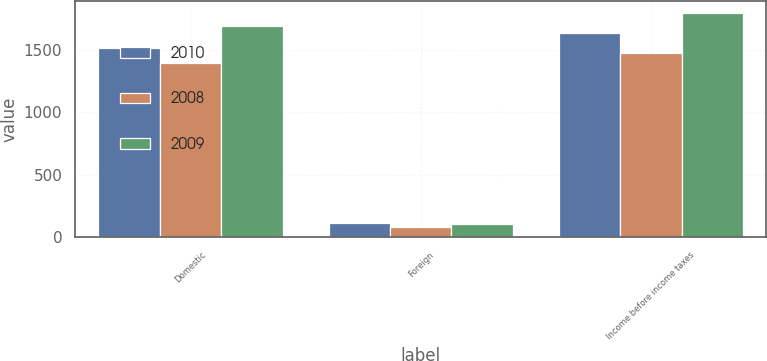Convert chart to OTSL. <chart><loc_0><loc_0><loc_500><loc_500><stacked_bar_chart><ecel><fcel>Domestic<fcel>Foreign<fcel>Income before income taxes<nl><fcel>2010<fcel>1517<fcel>114<fcel>1631<nl><fcel>2008<fcel>1396<fcel>77<fcel>1473<nl><fcel>2009<fcel>1693<fcel>104<fcel>1797<nl></chart> 